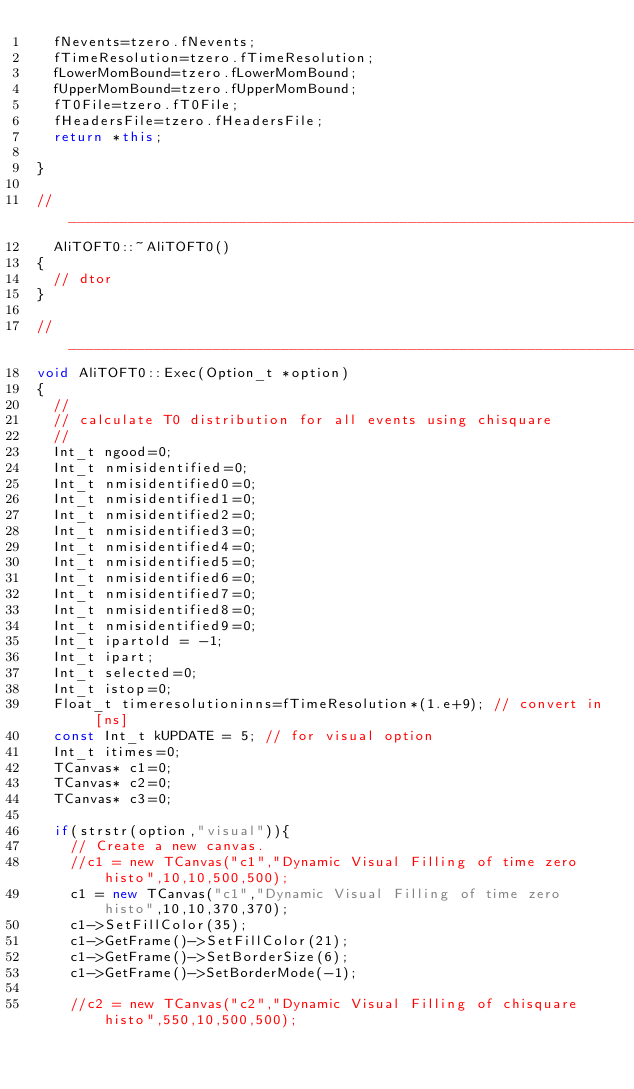Convert code to text. <code><loc_0><loc_0><loc_500><loc_500><_C++_>  fNevents=tzero.fNevents;
  fTimeResolution=tzero.fTimeResolution;
  fLowerMomBound=tzero.fLowerMomBound;
  fUpperMomBound=tzero.fUpperMomBound;
  fT0File=tzero.fT0File;
  fHeadersFile=tzero.fHeadersFile;
  return *this;

}

//____________________________________________________________________________ 
  AliTOFT0::~AliTOFT0()
{
  // dtor
}

//____________________________________________________________________________
void AliTOFT0::Exec(Option_t *option) 
{ 
  //
  // calculate T0 distribution for all events using chisquare 
  //
  Int_t ngood=0;
  Int_t nmisidentified=0;
  Int_t nmisidentified0=0;
  Int_t nmisidentified1=0;
  Int_t nmisidentified2=0;
  Int_t nmisidentified3=0;
  Int_t nmisidentified4=0;
  Int_t nmisidentified5=0;
  Int_t nmisidentified6=0;
  Int_t nmisidentified7=0;
  Int_t nmisidentified8=0;
  Int_t nmisidentified9=0;
  Int_t ipartold = -1;
  Int_t ipart;
  Int_t selected=0;
  Int_t istop=0;
  Float_t timeresolutioninns=fTimeResolution*(1.e+9); // convert in [ns]
  const Int_t kUPDATE = 5; // for visual option
  Int_t itimes=0;
  TCanvas* c1=0;
  TCanvas* c2=0;
  TCanvas* c3=0;

  if(strstr(option,"visual")){
    // Create a new canvas.
    //c1 = new TCanvas("c1","Dynamic Visual Filling of time zero histo",10,10,500,500);
    c1 = new TCanvas("c1","Dynamic Visual Filling of time zero histo",10,10,370,370);
    c1->SetFillColor(35);
    c1->GetFrame()->SetFillColor(21);
    c1->GetFrame()->SetBorderSize(6);
    c1->GetFrame()->SetBorderMode(-1);

    //c2 = new TCanvas("c2","Dynamic Visual Filling of chisquare histo",550,10,500,500);</code> 